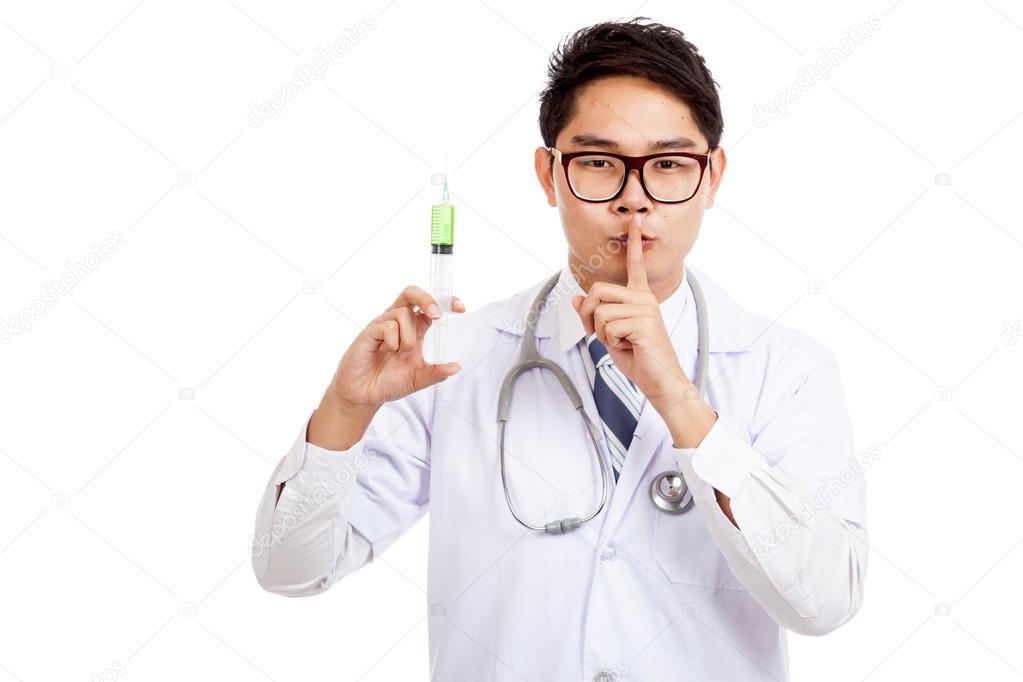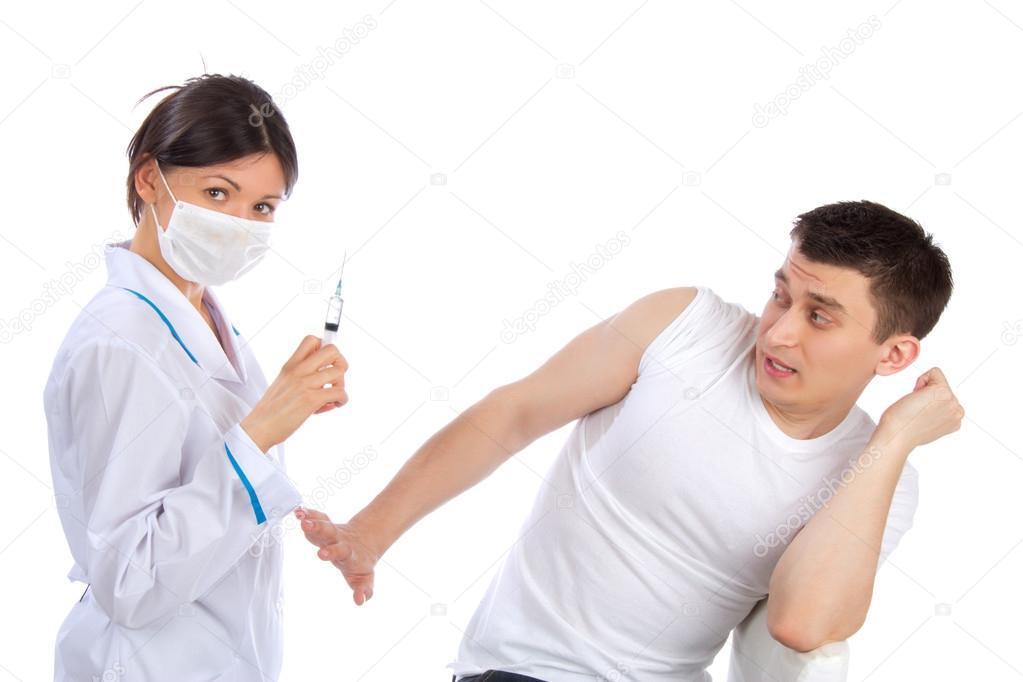The first image is the image on the left, the second image is the image on the right. Evaluate the accuracy of this statement regarding the images: "There is a woman visible in one of the images.". Is it true? Answer yes or no. Yes. The first image is the image on the left, the second image is the image on the right. Analyze the images presented: Is the assertion "Two doctors are looking at syringes." valid? Answer yes or no. No. 